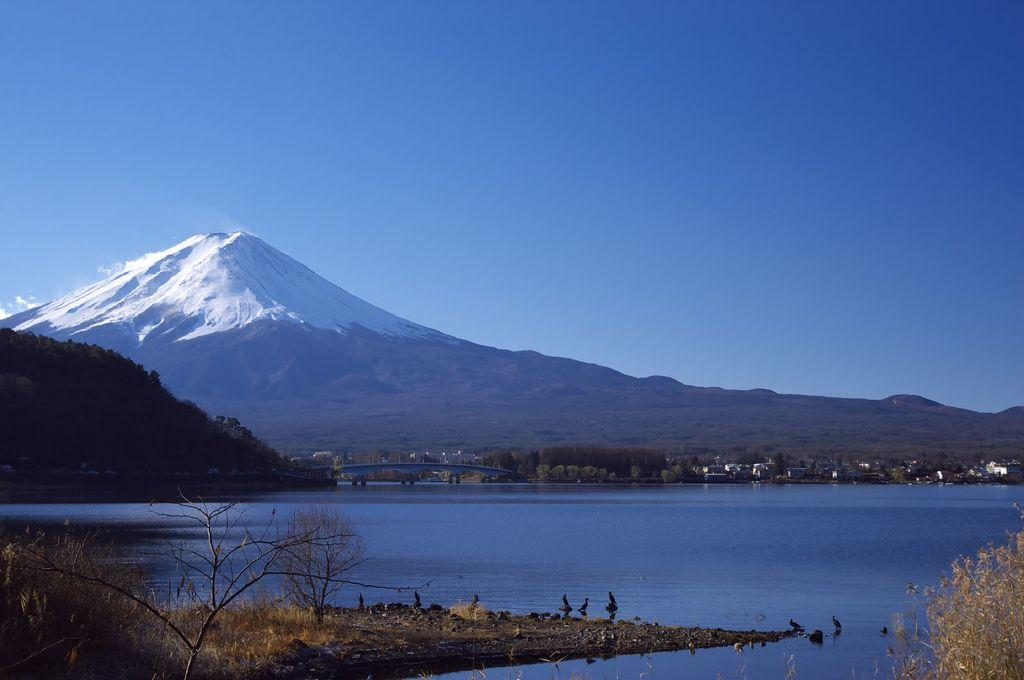What type of natural elements can be seen in the image? There are trees and hills visible in the image. What type of man-made structures can be seen in the image? There are buildings and a bridge visible in the image. What is visible at the top of the image? The sky is visible at the top of the image. What is visible at the bottom of the image? There is water visible at the bottom of the image. What type of animals can be seen in the image? There are birds visible in the image. Can you tell me where the record is located in the image? There is no record present in the image. Is there a hat visible on any of the birds in the image? There are no hats visible on the birds in the image. 